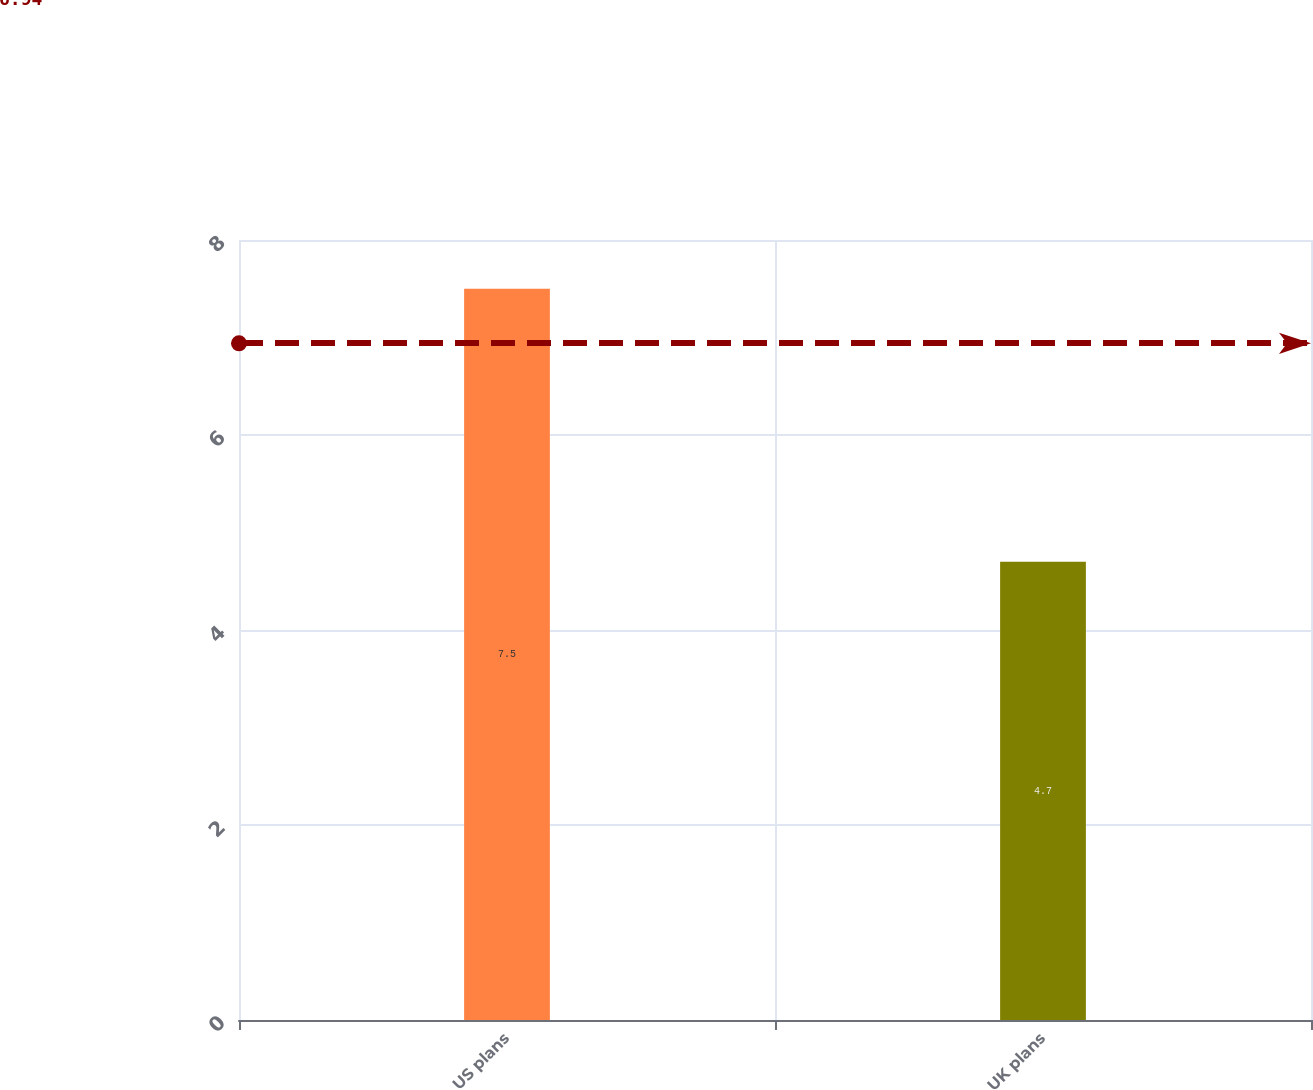<chart> <loc_0><loc_0><loc_500><loc_500><bar_chart><fcel>US plans<fcel>UK plans<nl><fcel>7.5<fcel>4.7<nl></chart> 